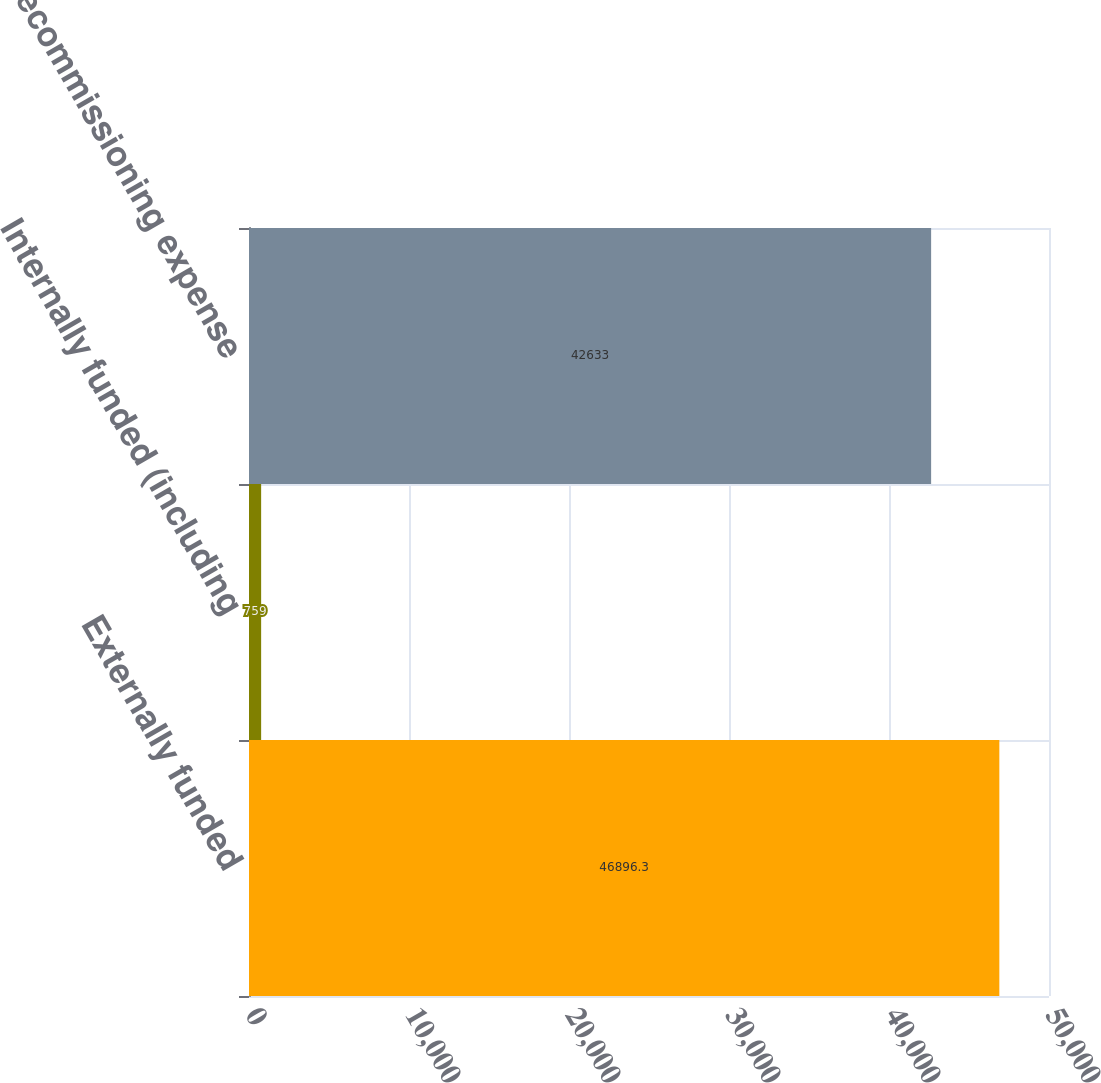Convert chart. <chart><loc_0><loc_0><loc_500><loc_500><bar_chart><fcel>Externally funded<fcel>Internally funded (including<fcel>Net decommissioning expense<nl><fcel>46896.3<fcel>759<fcel>42633<nl></chart> 